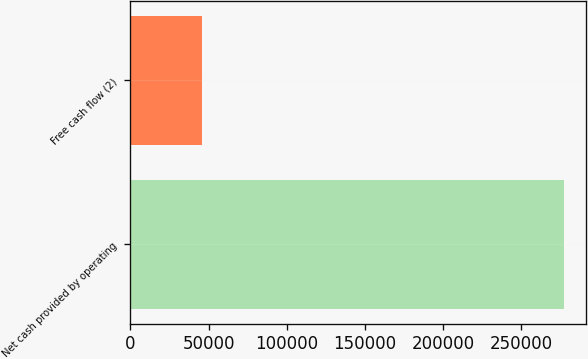Convert chart. <chart><loc_0><loc_0><loc_500><loc_500><bar_chart><fcel>Net cash provided by operating<fcel>Free cash flow (2)<nl><fcel>277420<fcel>45889<nl></chart> 